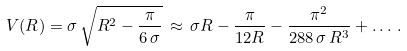<formula> <loc_0><loc_0><loc_500><loc_500>V ( R ) = \sigma \, \sqrt { R ^ { 2 } - \frac { \pi } { 6 \, \sigma } } \, \approx \, \sigma R - \frac { \pi } { 1 2 R } - \frac { \pi ^ { 2 } } { 2 8 8 \, \sigma \, R ^ { 3 } } + \dots \, .</formula> 